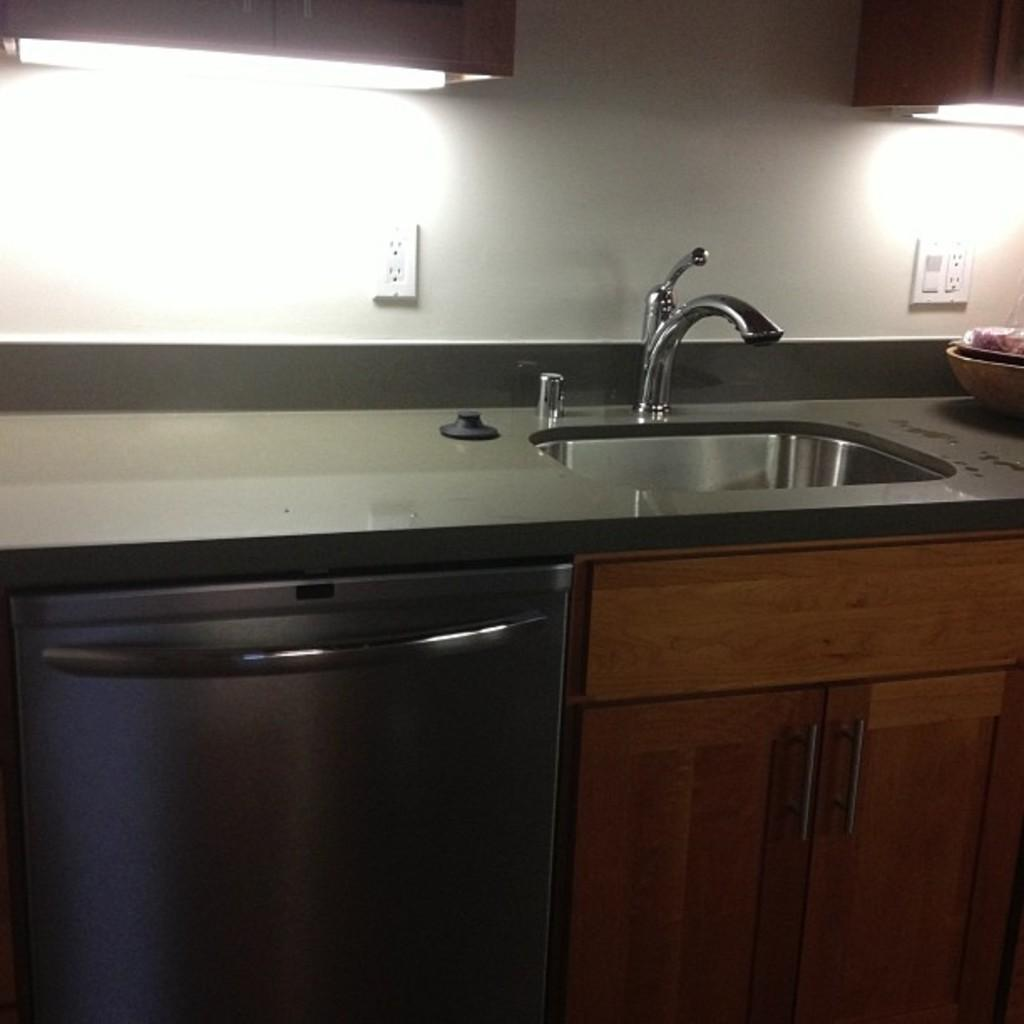What type of space is shown in the image? The image is an inside picture of a room. What type of furniture can be seen in the room? There are cupboards in the room. What is located on the countertop in the image? There is a sink and a bowl on the countertop. What can be found on the wall in the image? There are socket boards on the wall. What type of coal is being used to heat the room in the image? There is no coal present in the image, and the image does not depict any heating elements. 